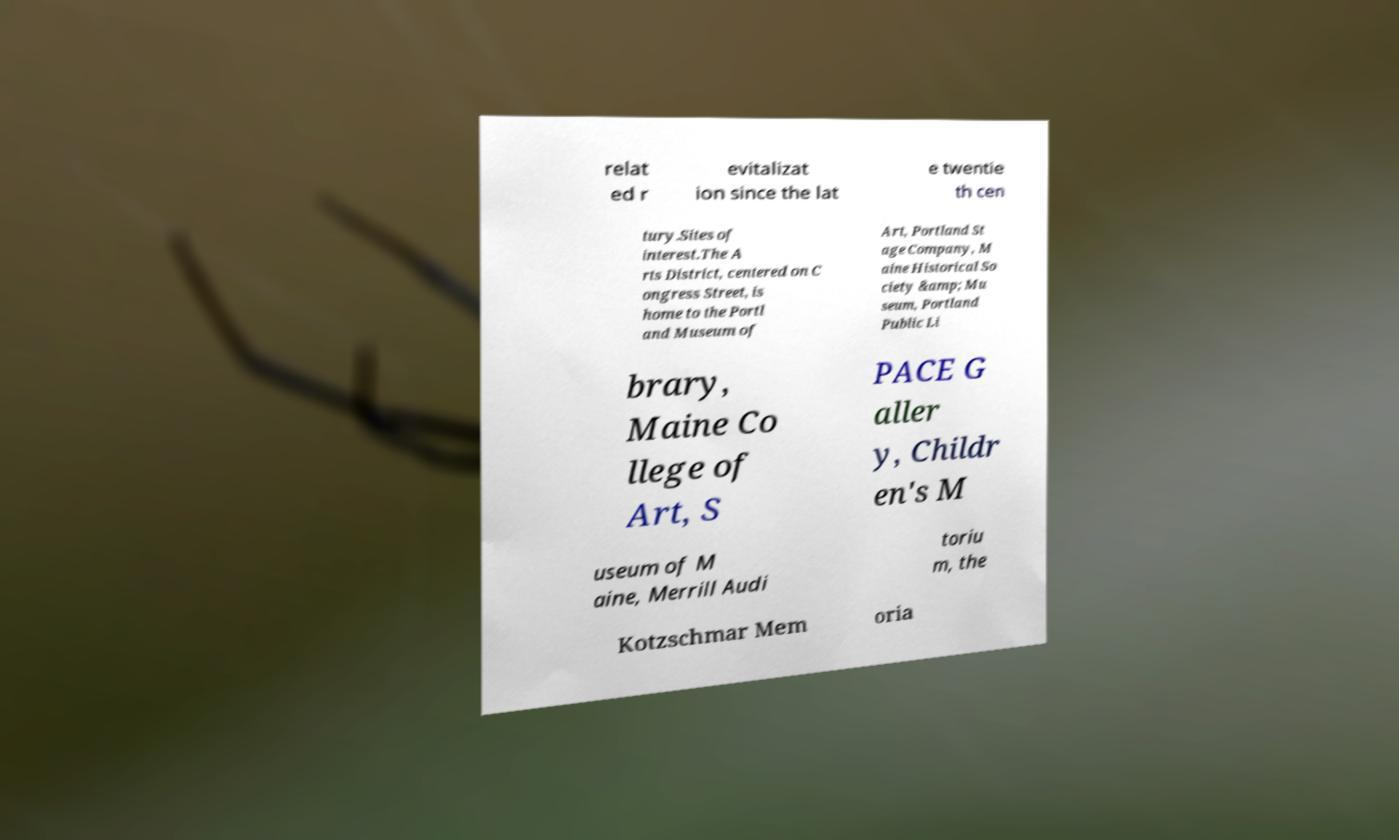Could you extract and type out the text from this image? relat ed r evitalizat ion since the lat e twentie th cen tury.Sites of interest.The A rts District, centered on C ongress Street, is home to the Portl and Museum of Art, Portland St age Company, M aine Historical So ciety &amp; Mu seum, Portland Public Li brary, Maine Co llege of Art, S PACE G aller y, Childr en's M useum of M aine, Merrill Audi toriu m, the Kotzschmar Mem oria 